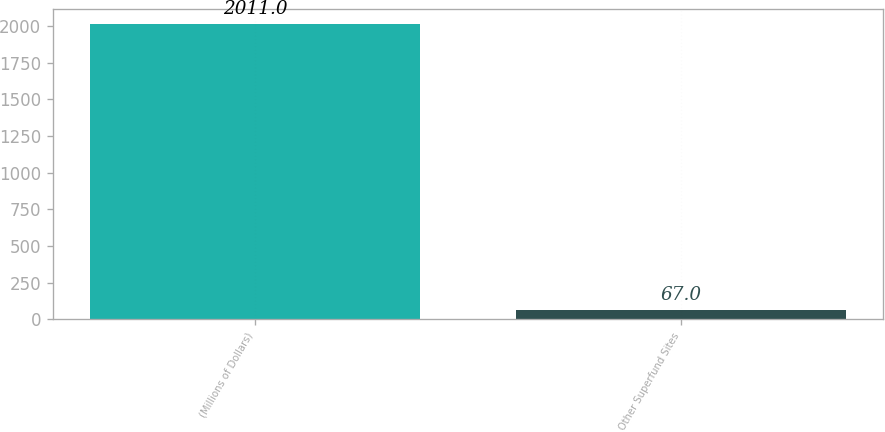<chart> <loc_0><loc_0><loc_500><loc_500><bar_chart><fcel>(Millions of Dollars)<fcel>Other Superfund Sites<nl><fcel>2011<fcel>67<nl></chart> 